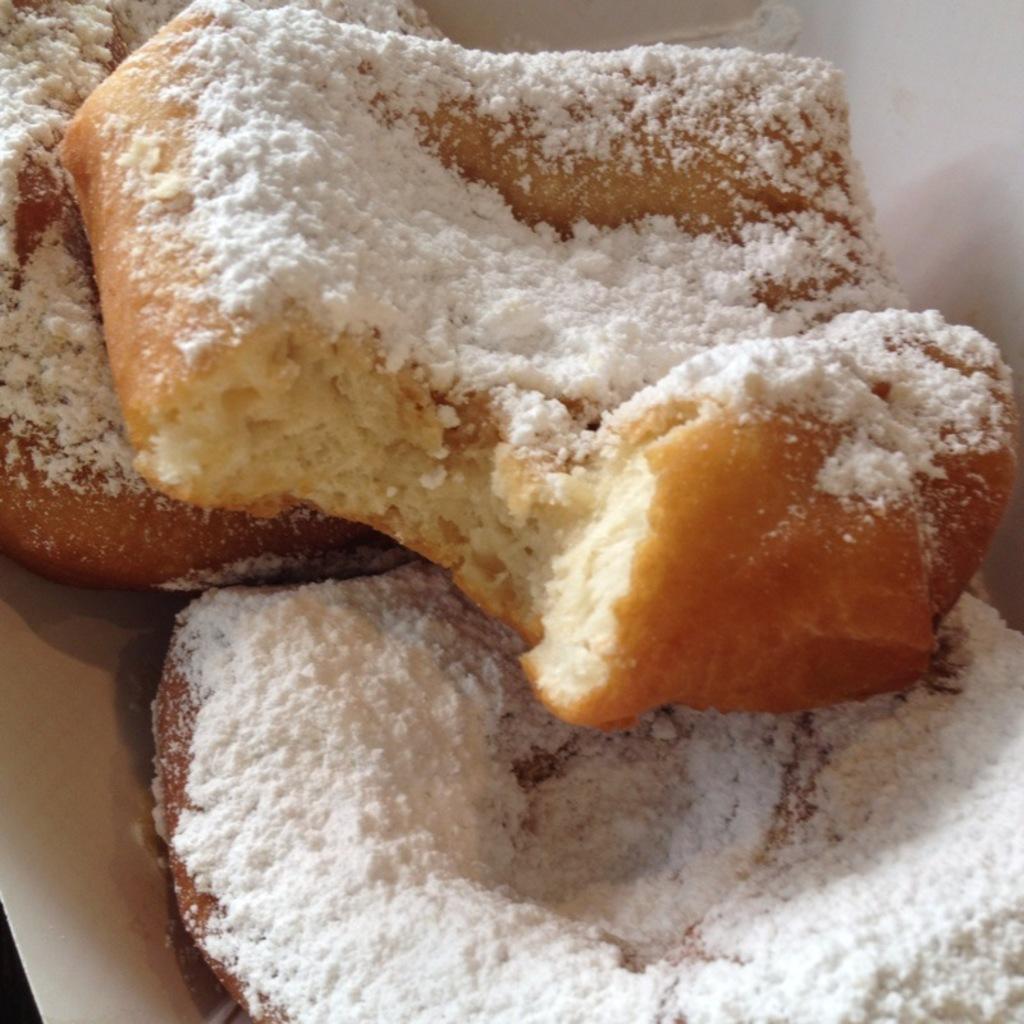Please provide a concise description of this image. In this image there is a plate with a food items on it. 